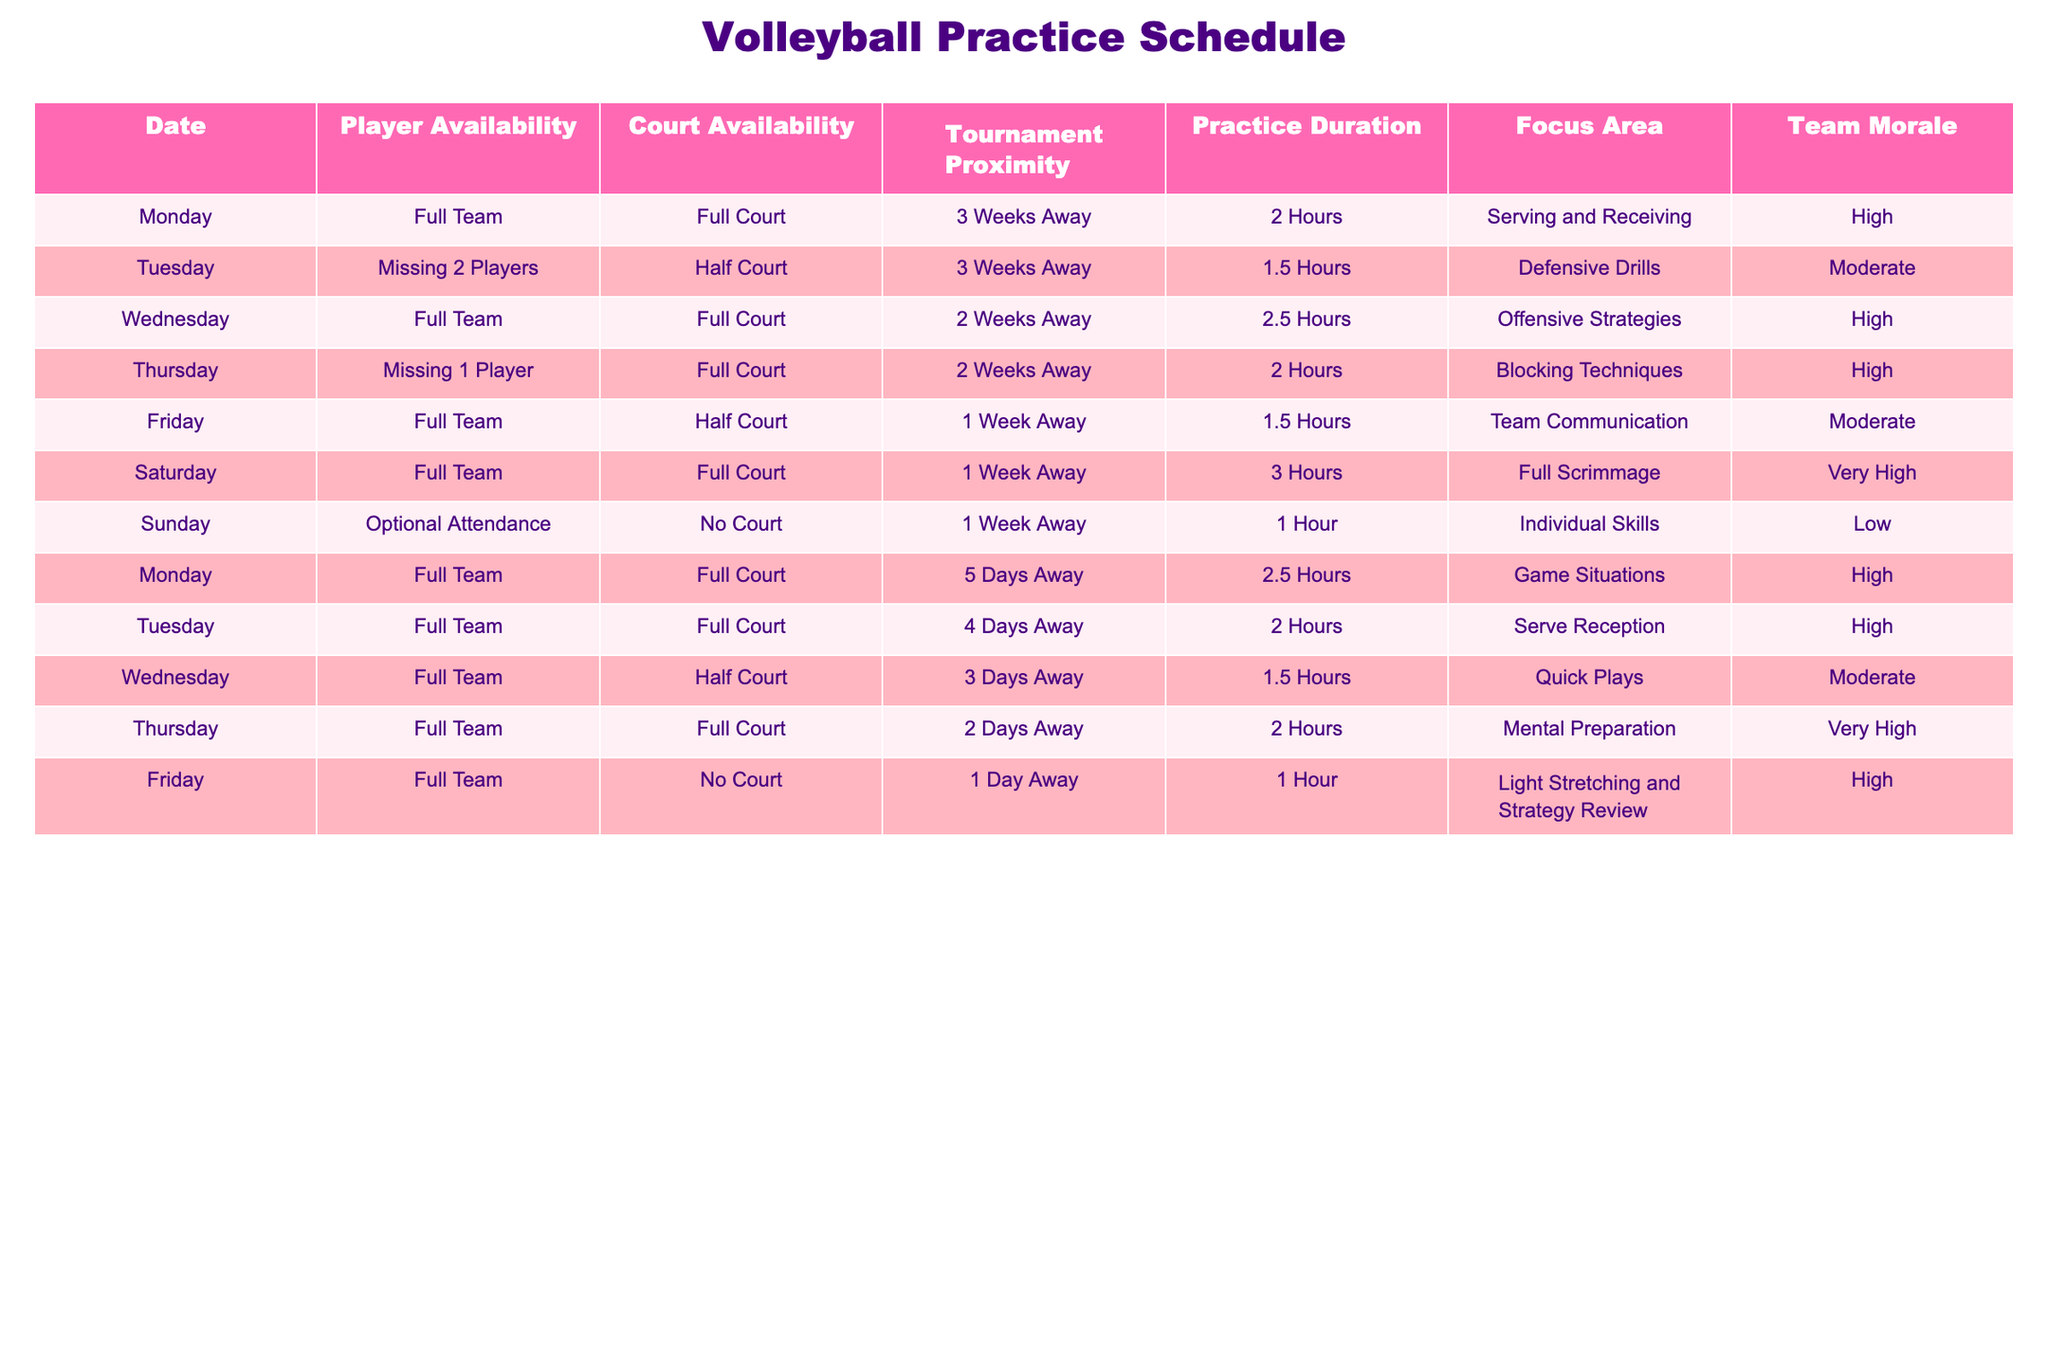What is the focus area for the practice on Wednesday of the week before the tournament? The table shows that on the Wednesday before the tournament, the focus area is "Quick Plays." This is directly read from the row corresponding to that date.
Answer: Quick Plays How many players are missing on Tuesday of the week before the tournament? Referring to Tuesday's entry for the week before the tournament, it notes that "Missing 2 Players." Therefore, the number of missing players is 2.
Answer: 2 What is the total practice duration for the practices in the week leading up to the tournament? For the week leading up to the tournament, the practice durations are 1.5 hours, 3 hours, 2.5 hours, and 1 hour. Adding these gives us: 1.5 + 3 + 2.5 + 1 = 8 hours total.
Answer: 8 hours On which day do we have the highest team morale? Evaluating the team morale column, we see that Saturday shows "Very High" morale, which is higher than any of the other practice days. Therefore, Saturday is recognized as the day with the highest morale.
Answer: Saturday Is there any day where the practice is scheduled but no court is available? By checking the table, it can be confirmed that on Sunday of the week before the tournament, it indicates "No Court." This validates that there is indeed a day scheduled for practice without court availability.
Answer: Yes What is the average duration of all practices scheduled for the week prior to the tournament? The durations for the week prior are 1.5 hours, 3 hours, 2.5 hours, and 1 hour. The sum of these durations is 8 hours. There are 4 practices, so the average is 8/4 = 2 hours.
Answer: 2 hours Which day has a focus area of "Blocking Techniques" and how does it compare to other focus areas? The entry for Thursday indicates that the focus area is "Blocking Techniques." Comparing this with other entries, we find focus areas like "Serving and Receiving," "Defensive Drills," etc., making "Blocking Techniques" a specialized individual practice area.
Answer: Thursday How many practices have "High" team morale as their rating? Reviewing the table, the practices with "High" morale listed include the ones on Monday, Wednesday, Thursday, and Friday, totaling to four practices.
Answer: 4 